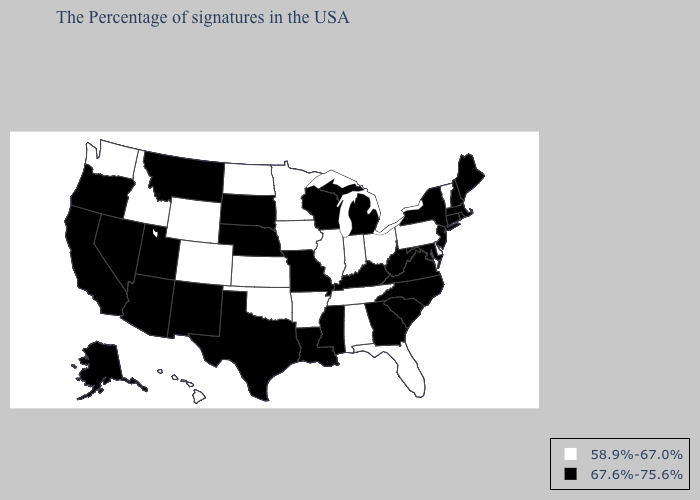Among the states that border Maine , which have the lowest value?
Write a very short answer. New Hampshire. Among the states that border Arkansas , does Texas have the lowest value?
Write a very short answer. No. Does Georgia have a higher value than Iowa?
Short answer required. Yes. What is the lowest value in states that border Michigan?
Be succinct. 58.9%-67.0%. What is the lowest value in the South?
Write a very short answer. 58.9%-67.0%. Does Maine have the lowest value in the USA?
Write a very short answer. No. Does the first symbol in the legend represent the smallest category?
Quick response, please. Yes. Does Missouri have the highest value in the MidWest?
Be succinct. Yes. Name the states that have a value in the range 67.6%-75.6%?
Write a very short answer. Maine, Massachusetts, Rhode Island, New Hampshire, Connecticut, New York, New Jersey, Maryland, Virginia, North Carolina, South Carolina, West Virginia, Georgia, Michigan, Kentucky, Wisconsin, Mississippi, Louisiana, Missouri, Nebraska, Texas, South Dakota, New Mexico, Utah, Montana, Arizona, Nevada, California, Oregon, Alaska. What is the lowest value in states that border South Carolina?
Quick response, please. 67.6%-75.6%. Name the states that have a value in the range 67.6%-75.6%?
Keep it brief. Maine, Massachusetts, Rhode Island, New Hampshire, Connecticut, New York, New Jersey, Maryland, Virginia, North Carolina, South Carolina, West Virginia, Georgia, Michigan, Kentucky, Wisconsin, Mississippi, Louisiana, Missouri, Nebraska, Texas, South Dakota, New Mexico, Utah, Montana, Arizona, Nevada, California, Oregon, Alaska. Which states have the lowest value in the MidWest?
Give a very brief answer. Ohio, Indiana, Illinois, Minnesota, Iowa, Kansas, North Dakota. Name the states that have a value in the range 58.9%-67.0%?
Keep it brief. Vermont, Delaware, Pennsylvania, Ohio, Florida, Indiana, Alabama, Tennessee, Illinois, Arkansas, Minnesota, Iowa, Kansas, Oklahoma, North Dakota, Wyoming, Colorado, Idaho, Washington, Hawaii. Does Alaska have a higher value than Missouri?
Be succinct. No. Name the states that have a value in the range 67.6%-75.6%?
Quick response, please. Maine, Massachusetts, Rhode Island, New Hampshire, Connecticut, New York, New Jersey, Maryland, Virginia, North Carolina, South Carolina, West Virginia, Georgia, Michigan, Kentucky, Wisconsin, Mississippi, Louisiana, Missouri, Nebraska, Texas, South Dakota, New Mexico, Utah, Montana, Arizona, Nevada, California, Oregon, Alaska. 